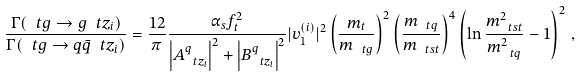<formula> <loc_0><loc_0><loc_500><loc_500>\frac { \Gamma ( \ t g \to g \ t z _ { i } ) } { \Gamma ( \ t g \to q \bar { q } \ t z _ { i } ) } = \frac { 1 2 } { \pi } \frac { \alpha _ { s } f _ { t } ^ { 2 } } { \left | A ^ { q } _ { \ t z _ { i } } \right | ^ { 2 } + \left | B ^ { q } _ { \ t z _ { i } } \right | ^ { 2 } } | v _ { 1 } ^ { ( i ) } | ^ { 2 } \left ( \frac { m _ { t } } { m _ { \ t g } } \right ) ^ { 2 } \left ( \frac { m _ { \ t q } } { m _ { \ t s t } } \right ) ^ { 4 } \left ( \ln \frac { m _ { \ t s t } ^ { 2 } } { m _ { \ t q } ^ { 2 } } - 1 \right ) ^ { 2 } \, ,</formula> 